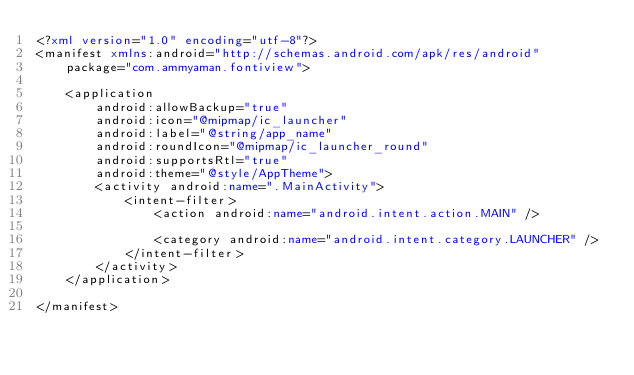<code> <loc_0><loc_0><loc_500><loc_500><_XML_><?xml version="1.0" encoding="utf-8"?>
<manifest xmlns:android="http://schemas.android.com/apk/res/android"
    package="com.ammyaman.fontiview">

    <application
        android:allowBackup="true"
        android:icon="@mipmap/ic_launcher"
        android:label="@string/app_name"
        android:roundIcon="@mipmap/ic_launcher_round"
        android:supportsRtl="true"
        android:theme="@style/AppTheme">
        <activity android:name=".MainActivity">
            <intent-filter>
                <action android:name="android.intent.action.MAIN" />

                <category android:name="android.intent.category.LAUNCHER" />
            </intent-filter>
        </activity>
    </application>

</manifest></code> 